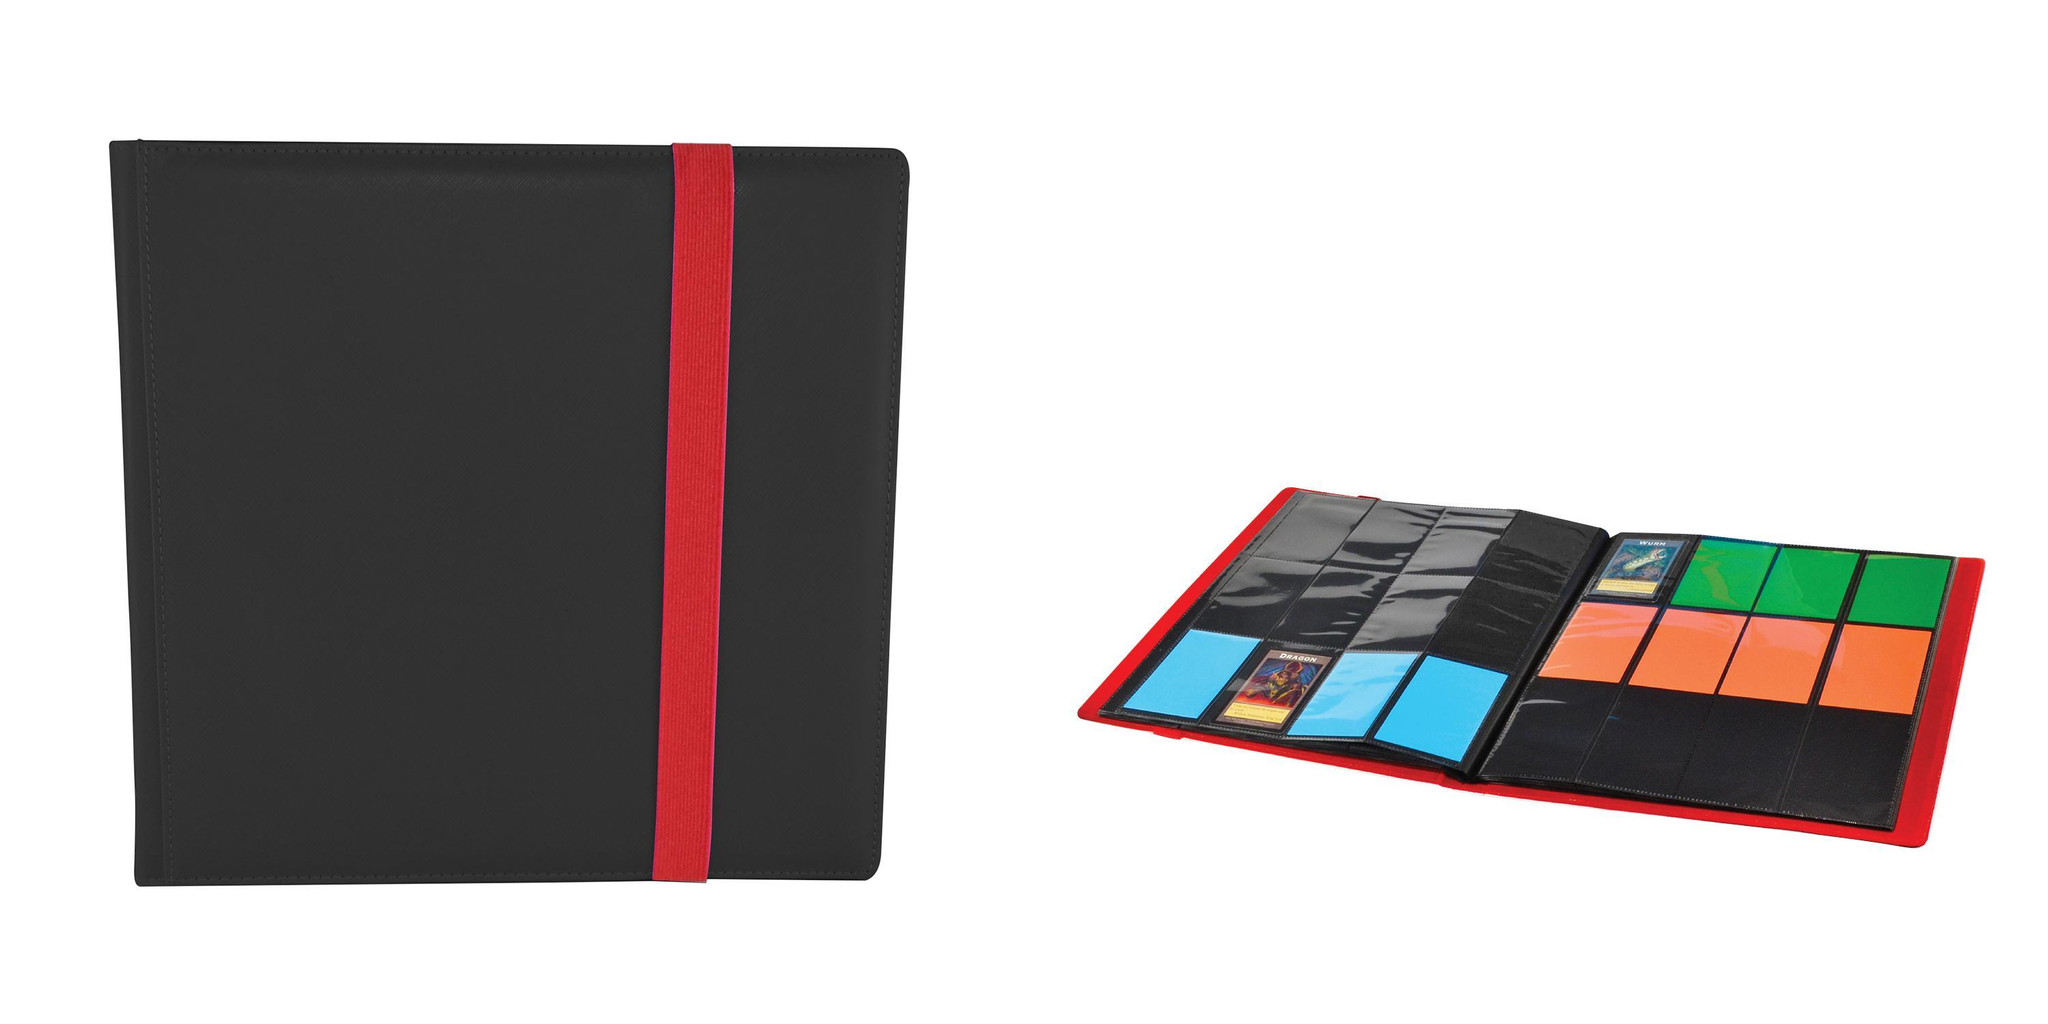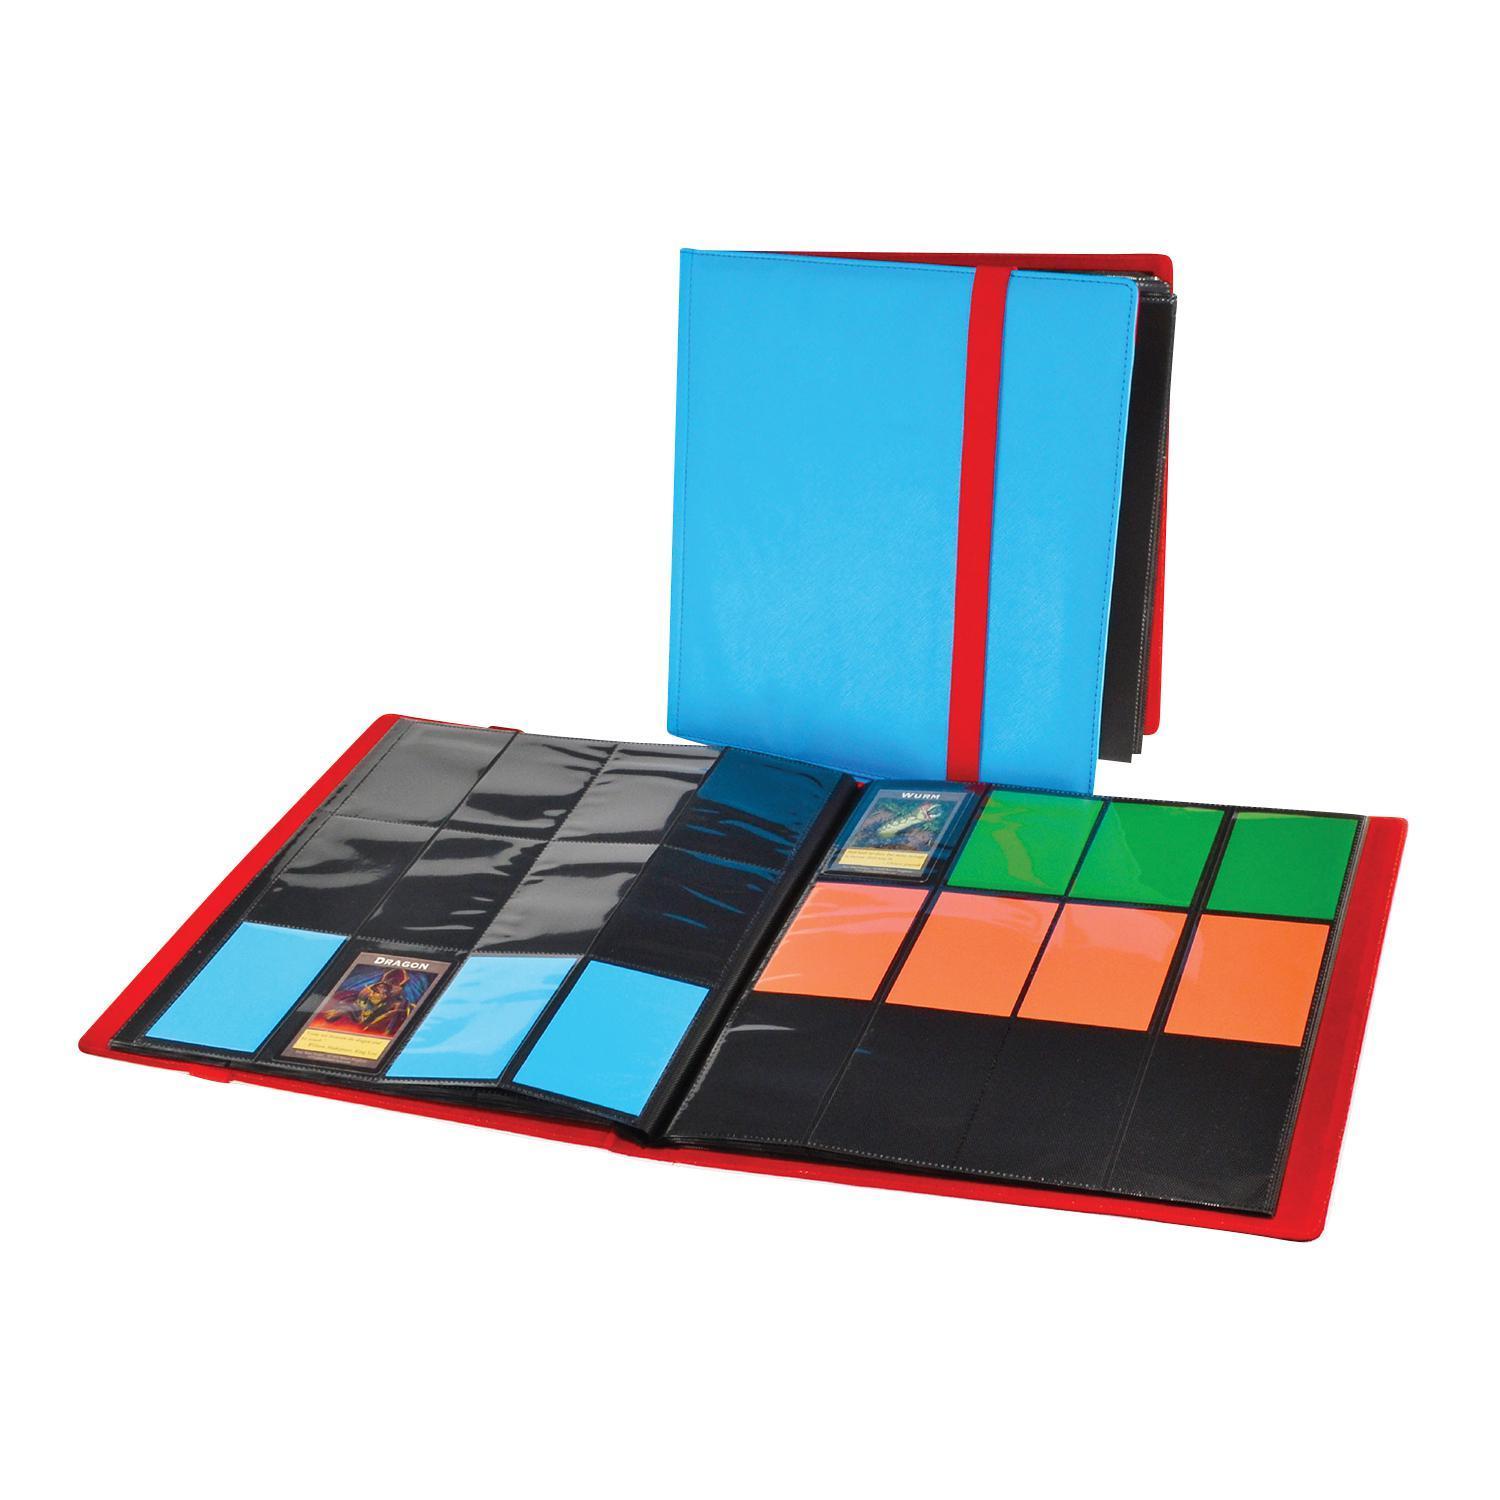The first image is the image on the left, the second image is the image on the right. Examine the images to the left and right. Is the description "There is a single folder on the left image." accurate? Answer yes or no. No. 